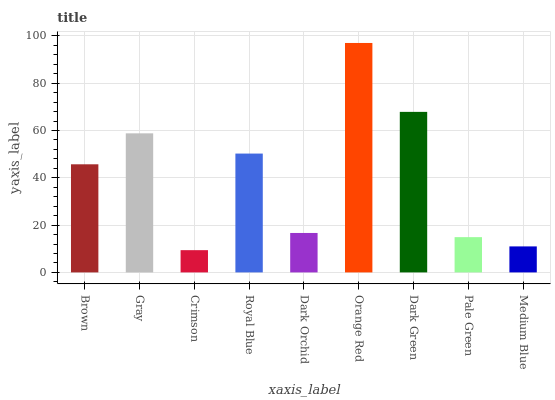Is Crimson the minimum?
Answer yes or no. Yes. Is Orange Red the maximum?
Answer yes or no. Yes. Is Gray the minimum?
Answer yes or no. No. Is Gray the maximum?
Answer yes or no. No. Is Gray greater than Brown?
Answer yes or no. Yes. Is Brown less than Gray?
Answer yes or no. Yes. Is Brown greater than Gray?
Answer yes or no. No. Is Gray less than Brown?
Answer yes or no. No. Is Brown the high median?
Answer yes or no. Yes. Is Brown the low median?
Answer yes or no. Yes. Is Pale Green the high median?
Answer yes or no. No. Is Dark Orchid the low median?
Answer yes or no. No. 